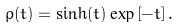Convert formula to latex. <formula><loc_0><loc_0><loc_500><loc_500>\rho ( t ) = \sinh ( t ) \exp \left [ - t \right ] .</formula> 